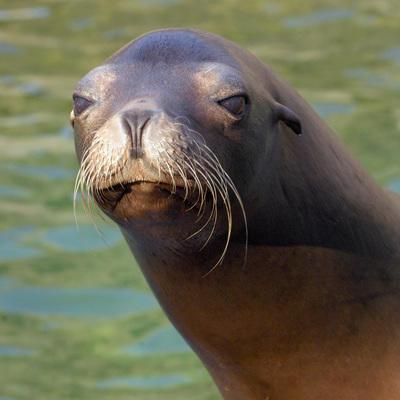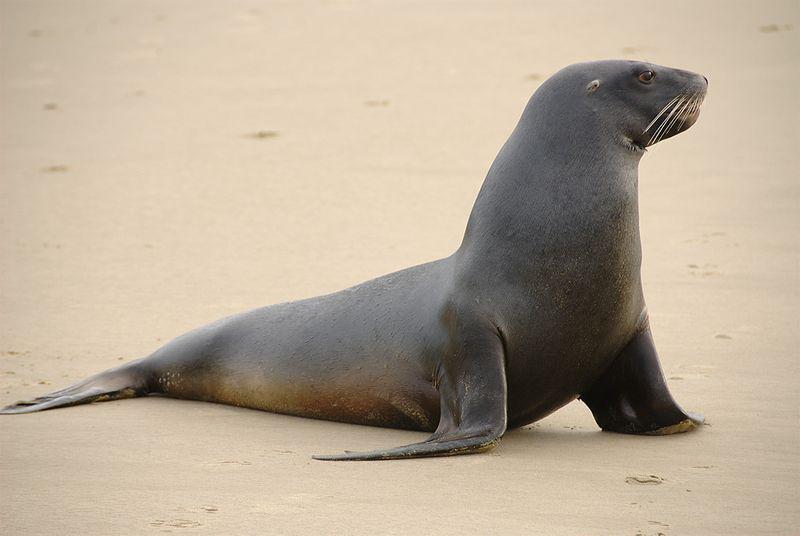The first image is the image on the left, the second image is the image on the right. For the images shown, is this caption "The seal in the right image is facing right." true? Answer yes or no. Yes. 